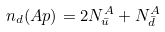Convert formula to latex. <formula><loc_0><loc_0><loc_500><loc_500>n _ { d } ( A p ) = 2 N _ { \bar { u } } ^ { A } + N _ { \bar { d } } ^ { A }</formula> 